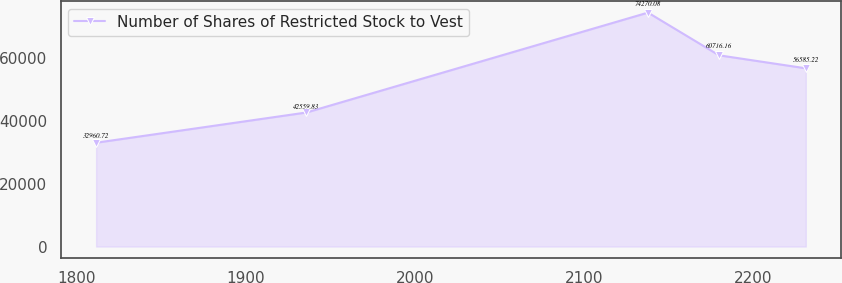Convert chart to OTSL. <chart><loc_0><loc_0><loc_500><loc_500><line_chart><ecel><fcel>Number of Shares of Restricted Stock to Vest<nl><fcel>1811.54<fcel>32960.7<nl><fcel>1935.84<fcel>42559.8<nl><fcel>2137.64<fcel>74270.1<nl><fcel>2179.57<fcel>60716.2<nl><fcel>2230.88<fcel>56585.2<nl></chart> 